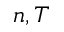<formula> <loc_0><loc_0><loc_500><loc_500>n , T</formula> 